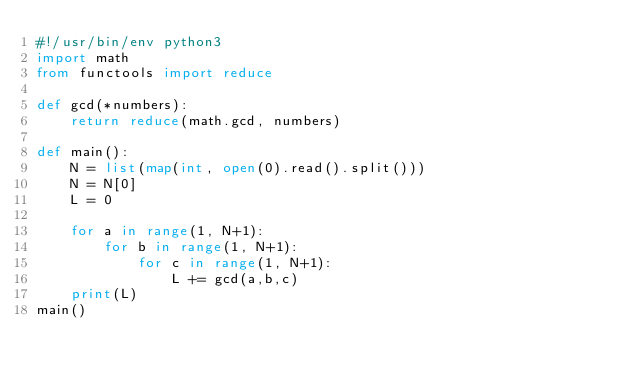<code> <loc_0><loc_0><loc_500><loc_500><_Python_>#!/usr/bin/env python3
import math
from functools import reduce
 
def gcd(*numbers):
    return reduce(math.gcd, numbers)
 
def main():
    N = list(map(int, open(0).read().split()))
    N = N[0]
    L = 0
 
    for a in range(1, N+1):
        for b in range(1, N+1):
            for c in range(1, N+1):
                L += gcd(a,b,c)
    print(L)
main()</code> 